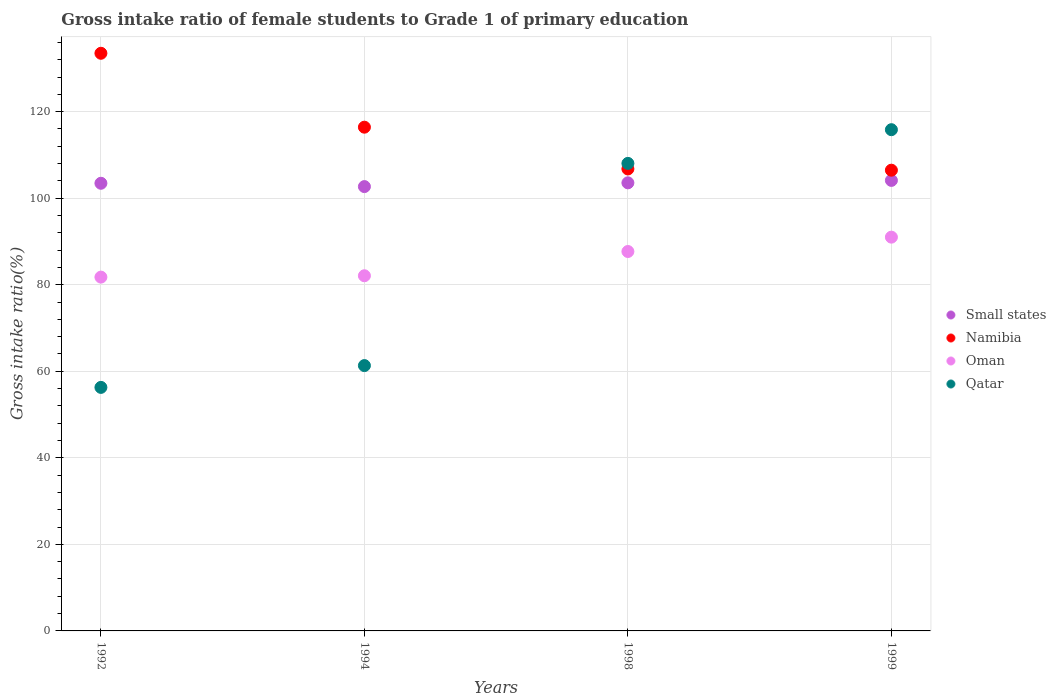Is the number of dotlines equal to the number of legend labels?
Ensure brevity in your answer.  Yes. What is the gross intake ratio in Small states in 1998?
Keep it short and to the point. 103.55. Across all years, what is the maximum gross intake ratio in Small states?
Provide a succinct answer. 104.11. Across all years, what is the minimum gross intake ratio in Oman?
Make the answer very short. 81.76. In which year was the gross intake ratio in Qatar maximum?
Your answer should be compact. 1999. In which year was the gross intake ratio in Oman minimum?
Your answer should be compact. 1992. What is the total gross intake ratio in Oman in the graph?
Provide a succinct answer. 342.52. What is the difference between the gross intake ratio in Small states in 1992 and that in 1998?
Your response must be concise. -0.1. What is the difference between the gross intake ratio in Oman in 1992 and the gross intake ratio in Namibia in 1994?
Your answer should be compact. -34.65. What is the average gross intake ratio in Small states per year?
Give a very brief answer. 103.45. In the year 1999, what is the difference between the gross intake ratio in Small states and gross intake ratio in Namibia?
Your answer should be very brief. -2.36. What is the ratio of the gross intake ratio in Small states in 1998 to that in 1999?
Offer a terse response. 0.99. Is the difference between the gross intake ratio in Small states in 1994 and 1998 greater than the difference between the gross intake ratio in Namibia in 1994 and 1998?
Your response must be concise. No. What is the difference between the highest and the second highest gross intake ratio in Namibia?
Offer a terse response. 17.08. What is the difference between the highest and the lowest gross intake ratio in Namibia?
Give a very brief answer. 27.02. Does the gross intake ratio in Qatar monotonically increase over the years?
Provide a short and direct response. Yes. Is the gross intake ratio in Oman strictly greater than the gross intake ratio in Small states over the years?
Offer a very short reply. No. Is the gross intake ratio in Oman strictly less than the gross intake ratio in Small states over the years?
Make the answer very short. Yes. Are the values on the major ticks of Y-axis written in scientific E-notation?
Provide a succinct answer. No. Does the graph contain grids?
Make the answer very short. Yes. How are the legend labels stacked?
Make the answer very short. Vertical. What is the title of the graph?
Your answer should be compact. Gross intake ratio of female students to Grade 1 of primary education. Does "Lao PDR" appear as one of the legend labels in the graph?
Offer a terse response. No. What is the label or title of the Y-axis?
Make the answer very short. Gross intake ratio(%). What is the Gross intake ratio(%) in Small states in 1992?
Provide a short and direct response. 103.45. What is the Gross intake ratio(%) in Namibia in 1992?
Ensure brevity in your answer.  133.49. What is the Gross intake ratio(%) of Oman in 1992?
Keep it short and to the point. 81.76. What is the Gross intake ratio(%) of Qatar in 1992?
Provide a succinct answer. 56.28. What is the Gross intake ratio(%) in Small states in 1994?
Your answer should be compact. 102.68. What is the Gross intake ratio(%) in Namibia in 1994?
Make the answer very short. 116.41. What is the Gross intake ratio(%) in Oman in 1994?
Ensure brevity in your answer.  82.08. What is the Gross intake ratio(%) of Qatar in 1994?
Provide a succinct answer. 61.32. What is the Gross intake ratio(%) in Small states in 1998?
Keep it short and to the point. 103.55. What is the Gross intake ratio(%) of Namibia in 1998?
Keep it short and to the point. 106.76. What is the Gross intake ratio(%) of Oman in 1998?
Make the answer very short. 87.68. What is the Gross intake ratio(%) in Qatar in 1998?
Keep it short and to the point. 108.04. What is the Gross intake ratio(%) of Small states in 1999?
Your answer should be very brief. 104.11. What is the Gross intake ratio(%) in Namibia in 1999?
Provide a succinct answer. 106.47. What is the Gross intake ratio(%) of Oman in 1999?
Your answer should be very brief. 91. What is the Gross intake ratio(%) of Qatar in 1999?
Your response must be concise. 115.83. Across all years, what is the maximum Gross intake ratio(%) in Small states?
Make the answer very short. 104.11. Across all years, what is the maximum Gross intake ratio(%) of Namibia?
Your answer should be compact. 133.49. Across all years, what is the maximum Gross intake ratio(%) in Oman?
Offer a terse response. 91. Across all years, what is the maximum Gross intake ratio(%) in Qatar?
Make the answer very short. 115.83. Across all years, what is the minimum Gross intake ratio(%) of Small states?
Offer a very short reply. 102.68. Across all years, what is the minimum Gross intake ratio(%) in Namibia?
Offer a terse response. 106.47. Across all years, what is the minimum Gross intake ratio(%) of Oman?
Offer a very short reply. 81.76. Across all years, what is the minimum Gross intake ratio(%) of Qatar?
Keep it short and to the point. 56.28. What is the total Gross intake ratio(%) of Small states in the graph?
Your response must be concise. 413.79. What is the total Gross intake ratio(%) of Namibia in the graph?
Provide a succinct answer. 463.12. What is the total Gross intake ratio(%) in Oman in the graph?
Offer a terse response. 342.52. What is the total Gross intake ratio(%) of Qatar in the graph?
Ensure brevity in your answer.  341.47. What is the difference between the Gross intake ratio(%) of Small states in 1992 and that in 1994?
Give a very brief answer. 0.77. What is the difference between the Gross intake ratio(%) of Namibia in 1992 and that in 1994?
Your answer should be very brief. 17.08. What is the difference between the Gross intake ratio(%) of Oman in 1992 and that in 1994?
Provide a succinct answer. -0.31. What is the difference between the Gross intake ratio(%) in Qatar in 1992 and that in 1994?
Your answer should be very brief. -5.04. What is the difference between the Gross intake ratio(%) of Small states in 1992 and that in 1998?
Give a very brief answer. -0.1. What is the difference between the Gross intake ratio(%) of Namibia in 1992 and that in 1998?
Make the answer very short. 26.73. What is the difference between the Gross intake ratio(%) in Oman in 1992 and that in 1998?
Make the answer very short. -5.92. What is the difference between the Gross intake ratio(%) of Qatar in 1992 and that in 1998?
Provide a short and direct response. -51.77. What is the difference between the Gross intake ratio(%) in Small states in 1992 and that in 1999?
Your answer should be very brief. -0.66. What is the difference between the Gross intake ratio(%) of Namibia in 1992 and that in 1999?
Keep it short and to the point. 27.02. What is the difference between the Gross intake ratio(%) of Oman in 1992 and that in 1999?
Your response must be concise. -9.24. What is the difference between the Gross intake ratio(%) in Qatar in 1992 and that in 1999?
Give a very brief answer. -59.55. What is the difference between the Gross intake ratio(%) in Small states in 1994 and that in 1998?
Your answer should be very brief. -0.87. What is the difference between the Gross intake ratio(%) in Namibia in 1994 and that in 1998?
Give a very brief answer. 9.65. What is the difference between the Gross intake ratio(%) in Oman in 1994 and that in 1998?
Your answer should be compact. -5.61. What is the difference between the Gross intake ratio(%) of Qatar in 1994 and that in 1998?
Keep it short and to the point. -46.73. What is the difference between the Gross intake ratio(%) of Small states in 1994 and that in 1999?
Keep it short and to the point. -1.43. What is the difference between the Gross intake ratio(%) in Namibia in 1994 and that in 1999?
Your response must be concise. 9.94. What is the difference between the Gross intake ratio(%) of Oman in 1994 and that in 1999?
Keep it short and to the point. -8.92. What is the difference between the Gross intake ratio(%) of Qatar in 1994 and that in 1999?
Give a very brief answer. -54.51. What is the difference between the Gross intake ratio(%) in Small states in 1998 and that in 1999?
Give a very brief answer. -0.56. What is the difference between the Gross intake ratio(%) of Namibia in 1998 and that in 1999?
Your answer should be compact. 0.28. What is the difference between the Gross intake ratio(%) in Oman in 1998 and that in 1999?
Make the answer very short. -3.32. What is the difference between the Gross intake ratio(%) in Qatar in 1998 and that in 1999?
Your response must be concise. -7.79. What is the difference between the Gross intake ratio(%) in Small states in 1992 and the Gross intake ratio(%) in Namibia in 1994?
Your response must be concise. -12.96. What is the difference between the Gross intake ratio(%) of Small states in 1992 and the Gross intake ratio(%) of Oman in 1994?
Keep it short and to the point. 21.37. What is the difference between the Gross intake ratio(%) in Small states in 1992 and the Gross intake ratio(%) in Qatar in 1994?
Give a very brief answer. 42.13. What is the difference between the Gross intake ratio(%) of Namibia in 1992 and the Gross intake ratio(%) of Oman in 1994?
Keep it short and to the point. 51.41. What is the difference between the Gross intake ratio(%) of Namibia in 1992 and the Gross intake ratio(%) of Qatar in 1994?
Offer a terse response. 72.17. What is the difference between the Gross intake ratio(%) of Oman in 1992 and the Gross intake ratio(%) of Qatar in 1994?
Give a very brief answer. 20.44. What is the difference between the Gross intake ratio(%) of Small states in 1992 and the Gross intake ratio(%) of Namibia in 1998?
Your response must be concise. -3.31. What is the difference between the Gross intake ratio(%) in Small states in 1992 and the Gross intake ratio(%) in Oman in 1998?
Provide a succinct answer. 15.77. What is the difference between the Gross intake ratio(%) of Small states in 1992 and the Gross intake ratio(%) of Qatar in 1998?
Your answer should be very brief. -4.59. What is the difference between the Gross intake ratio(%) in Namibia in 1992 and the Gross intake ratio(%) in Oman in 1998?
Offer a very short reply. 45.81. What is the difference between the Gross intake ratio(%) of Namibia in 1992 and the Gross intake ratio(%) of Qatar in 1998?
Provide a succinct answer. 25.45. What is the difference between the Gross intake ratio(%) of Oman in 1992 and the Gross intake ratio(%) of Qatar in 1998?
Give a very brief answer. -26.28. What is the difference between the Gross intake ratio(%) of Small states in 1992 and the Gross intake ratio(%) of Namibia in 1999?
Your answer should be very brief. -3.02. What is the difference between the Gross intake ratio(%) of Small states in 1992 and the Gross intake ratio(%) of Oman in 1999?
Provide a succinct answer. 12.45. What is the difference between the Gross intake ratio(%) of Small states in 1992 and the Gross intake ratio(%) of Qatar in 1999?
Offer a terse response. -12.38. What is the difference between the Gross intake ratio(%) in Namibia in 1992 and the Gross intake ratio(%) in Oman in 1999?
Offer a terse response. 42.49. What is the difference between the Gross intake ratio(%) in Namibia in 1992 and the Gross intake ratio(%) in Qatar in 1999?
Provide a short and direct response. 17.66. What is the difference between the Gross intake ratio(%) in Oman in 1992 and the Gross intake ratio(%) in Qatar in 1999?
Your response must be concise. -34.07. What is the difference between the Gross intake ratio(%) of Small states in 1994 and the Gross intake ratio(%) of Namibia in 1998?
Your answer should be compact. -4.08. What is the difference between the Gross intake ratio(%) of Small states in 1994 and the Gross intake ratio(%) of Oman in 1998?
Offer a terse response. 15. What is the difference between the Gross intake ratio(%) of Small states in 1994 and the Gross intake ratio(%) of Qatar in 1998?
Provide a short and direct response. -5.36. What is the difference between the Gross intake ratio(%) of Namibia in 1994 and the Gross intake ratio(%) of Oman in 1998?
Ensure brevity in your answer.  28.73. What is the difference between the Gross intake ratio(%) in Namibia in 1994 and the Gross intake ratio(%) in Qatar in 1998?
Your answer should be compact. 8.37. What is the difference between the Gross intake ratio(%) of Oman in 1994 and the Gross intake ratio(%) of Qatar in 1998?
Keep it short and to the point. -25.97. What is the difference between the Gross intake ratio(%) of Small states in 1994 and the Gross intake ratio(%) of Namibia in 1999?
Ensure brevity in your answer.  -3.79. What is the difference between the Gross intake ratio(%) of Small states in 1994 and the Gross intake ratio(%) of Oman in 1999?
Offer a very short reply. 11.68. What is the difference between the Gross intake ratio(%) of Small states in 1994 and the Gross intake ratio(%) of Qatar in 1999?
Make the answer very short. -13.15. What is the difference between the Gross intake ratio(%) of Namibia in 1994 and the Gross intake ratio(%) of Oman in 1999?
Provide a succinct answer. 25.41. What is the difference between the Gross intake ratio(%) of Namibia in 1994 and the Gross intake ratio(%) of Qatar in 1999?
Your answer should be very brief. 0.58. What is the difference between the Gross intake ratio(%) in Oman in 1994 and the Gross intake ratio(%) in Qatar in 1999?
Provide a succinct answer. -33.75. What is the difference between the Gross intake ratio(%) in Small states in 1998 and the Gross intake ratio(%) in Namibia in 1999?
Ensure brevity in your answer.  -2.92. What is the difference between the Gross intake ratio(%) in Small states in 1998 and the Gross intake ratio(%) in Oman in 1999?
Keep it short and to the point. 12.55. What is the difference between the Gross intake ratio(%) in Small states in 1998 and the Gross intake ratio(%) in Qatar in 1999?
Provide a succinct answer. -12.28. What is the difference between the Gross intake ratio(%) in Namibia in 1998 and the Gross intake ratio(%) in Oman in 1999?
Make the answer very short. 15.76. What is the difference between the Gross intake ratio(%) in Namibia in 1998 and the Gross intake ratio(%) in Qatar in 1999?
Provide a short and direct response. -9.08. What is the difference between the Gross intake ratio(%) of Oman in 1998 and the Gross intake ratio(%) of Qatar in 1999?
Provide a succinct answer. -28.15. What is the average Gross intake ratio(%) in Small states per year?
Provide a short and direct response. 103.45. What is the average Gross intake ratio(%) in Namibia per year?
Keep it short and to the point. 115.78. What is the average Gross intake ratio(%) in Oman per year?
Give a very brief answer. 85.63. What is the average Gross intake ratio(%) of Qatar per year?
Your response must be concise. 85.37. In the year 1992, what is the difference between the Gross intake ratio(%) in Small states and Gross intake ratio(%) in Namibia?
Give a very brief answer. -30.04. In the year 1992, what is the difference between the Gross intake ratio(%) of Small states and Gross intake ratio(%) of Oman?
Provide a succinct answer. 21.69. In the year 1992, what is the difference between the Gross intake ratio(%) in Small states and Gross intake ratio(%) in Qatar?
Ensure brevity in your answer.  47.17. In the year 1992, what is the difference between the Gross intake ratio(%) of Namibia and Gross intake ratio(%) of Oman?
Provide a short and direct response. 51.73. In the year 1992, what is the difference between the Gross intake ratio(%) in Namibia and Gross intake ratio(%) in Qatar?
Offer a terse response. 77.21. In the year 1992, what is the difference between the Gross intake ratio(%) of Oman and Gross intake ratio(%) of Qatar?
Give a very brief answer. 25.48. In the year 1994, what is the difference between the Gross intake ratio(%) of Small states and Gross intake ratio(%) of Namibia?
Give a very brief answer. -13.73. In the year 1994, what is the difference between the Gross intake ratio(%) in Small states and Gross intake ratio(%) in Oman?
Make the answer very short. 20.6. In the year 1994, what is the difference between the Gross intake ratio(%) of Small states and Gross intake ratio(%) of Qatar?
Make the answer very short. 41.36. In the year 1994, what is the difference between the Gross intake ratio(%) of Namibia and Gross intake ratio(%) of Oman?
Make the answer very short. 34.33. In the year 1994, what is the difference between the Gross intake ratio(%) in Namibia and Gross intake ratio(%) in Qatar?
Keep it short and to the point. 55.09. In the year 1994, what is the difference between the Gross intake ratio(%) of Oman and Gross intake ratio(%) of Qatar?
Provide a short and direct response. 20.76. In the year 1998, what is the difference between the Gross intake ratio(%) of Small states and Gross intake ratio(%) of Namibia?
Your answer should be compact. -3.21. In the year 1998, what is the difference between the Gross intake ratio(%) of Small states and Gross intake ratio(%) of Oman?
Ensure brevity in your answer.  15.87. In the year 1998, what is the difference between the Gross intake ratio(%) in Small states and Gross intake ratio(%) in Qatar?
Your answer should be very brief. -4.49. In the year 1998, what is the difference between the Gross intake ratio(%) of Namibia and Gross intake ratio(%) of Oman?
Ensure brevity in your answer.  19.07. In the year 1998, what is the difference between the Gross intake ratio(%) in Namibia and Gross intake ratio(%) in Qatar?
Offer a terse response. -1.29. In the year 1998, what is the difference between the Gross intake ratio(%) in Oman and Gross intake ratio(%) in Qatar?
Provide a short and direct response. -20.36. In the year 1999, what is the difference between the Gross intake ratio(%) of Small states and Gross intake ratio(%) of Namibia?
Ensure brevity in your answer.  -2.36. In the year 1999, what is the difference between the Gross intake ratio(%) of Small states and Gross intake ratio(%) of Oman?
Keep it short and to the point. 13.11. In the year 1999, what is the difference between the Gross intake ratio(%) of Small states and Gross intake ratio(%) of Qatar?
Keep it short and to the point. -11.72. In the year 1999, what is the difference between the Gross intake ratio(%) in Namibia and Gross intake ratio(%) in Oman?
Ensure brevity in your answer.  15.47. In the year 1999, what is the difference between the Gross intake ratio(%) in Namibia and Gross intake ratio(%) in Qatar?
Offer a very short reply. -9.36. In the year 1999, what is the difference between the Gross intake ratio(%) of Oman and Gross intake ratio(%) of Qatar?
Give a very brief answer. -24.83. What is the ratio of the Gross intake ratio(%) of Small states in 1992 to that in 1994?
Offer a very short reply. 1.01. What is the ratio of the Gross intake ratio(%) in Namibia in 1992 to that in 1994?
Keep it short and to the point. 1.15. What is the ratio of the Gross intake ratio(%) in Qatar in 1992 to that in 1994?
Keep it short and to the point. 0.92. What is the ratio of the Gross intake ratio(%) of Namibia in 1992 to that in 1998?
Your answer should be very brief. 1.25. What is the ratio of the Gross intake ratio(%) of Oman in 1992 to that in 1998?
Make the answer very short. 0.93. What is the ratio of the Gross intake ratio(%) in Qatar in 1992 to that in 1998?
Keep it short and to the point. 0.52. What is the ratio of the Gross intake ratio(%) in Namibia in 1992 to that in 1999?
Keep it short and to the point. 1.25. What is the ratio of the Gross intake ratio(%) of Oman in 1992 to that in 1999?
Your response must be concise. 0.9. What is the ratio of the Gross intake ratio(%) of Qatar in 1992 to that in 1999?
Make the answer very short. 0.49. What is the ratio of the Gross intake ratio(%) of Small states in 1994 to that in 1998?
Keep it short and to the point. 0.99. What is the ratio of the Gross intake ratio(%) of Namibia in 1994 to that in 1998?
Offer a very short reply. 1.09. What is the ratio of the Gross intake ratio(%) in Oman in 1994 to that in 1998?
Provide a succinct answer. 0.94. What is the ratio of the Gross intake ratio(%) of Qatar in 1994 to that in 1998?
Ensure brevity in your answer.  0.57. What is the ratio of the Gross intake ratio(%) in Small states in 1994 to that in 1999?
Provide a succinct answer. 0.99. What is the ratio of the Gross intake ratio(%) of Namibia in 1994 to that in 1999?
Keep it short and to the point. 1.09. What is the ratio of the Gross intake ratio(%) in Oman in 1994 to that in 1999?
Your answer should be very brief. 0.9. What is the ratio of the Gross intake ratio(%) in Qatar in 1994 to that in 1999?
Make the answer very short. 0.53. What is the ratio of the Gross intake ratio(%) in Small states in 1998 to that in 1999?
Your response must be concise. 0.99. What is the ratio of the Gross intake ratio(%) in Namibia in 1998 to that in 1999?
Keep it short and to the point. 1. What is the ratio of the Gross intake ratio(%) of Oman in 1998 to that in 1999?
Offer a very short reply. 0.96. What is the ratio of the Gross intake ratio(%) of Qatar in 1998 to that in 1999?
Make the answer very short. 0.93. What is the difference between the highest and the second highest Gross intake ratio(%) of Small states?
Your response must be concise. 0.56. What is the difference between the highest and the second highest Gross intake ratio(%) in Namibia?
Offer a terse response. 17.08. What is the difference between the highest and the second highest Gross intake ratio(%) in Oman?
Ensure brevity in your answer.  3.32. What is the difference between the highest and the second highest Gross intake ratio(%) in Qatar?
Your answer should be very brief. 7.79. What is the difference between the highest and the lowest Gross intake ratio(%) in Small states?
Keep it short and to the point. 1.43. What is the difference between the highest and the lowest Gross intake ratio(%) of Namibia?
Your answer should be very brief. 27.02. What is the difference between the highest and the lowest Gross intake ratio(%) of Oman?
Provide a short and direct response. 9.24. What is the difference between the highest and the lowest Gross intake ratio(%) in Qatar?
Make the answer very short. 59.55. 